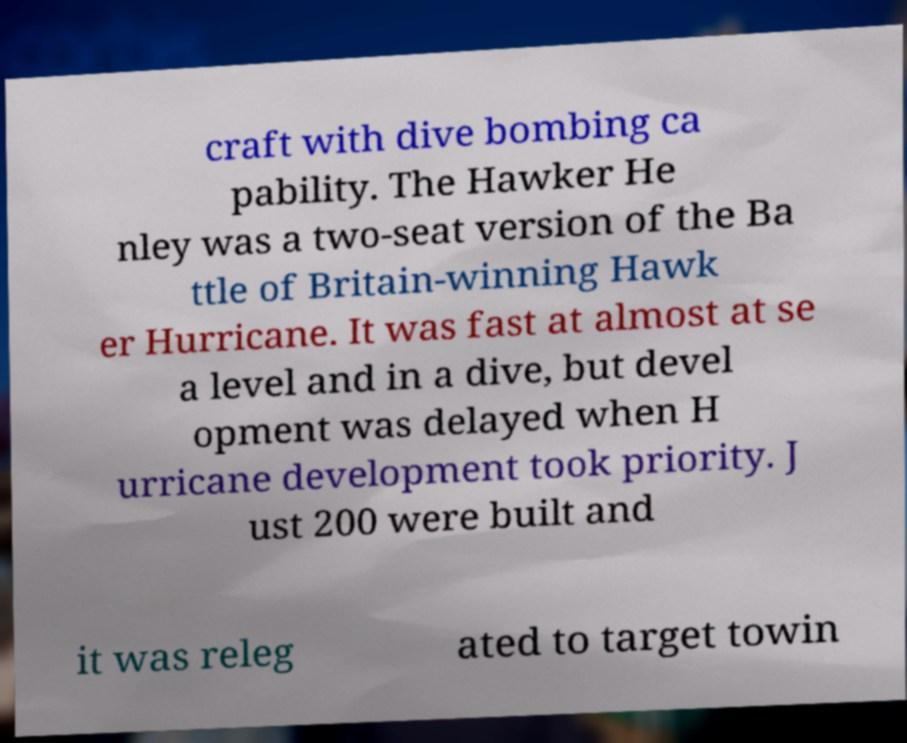Can you read and provide the text displayed in the image?This photo seems to have some interesting text. Can you extract and type it out for me? craft with dive bombing ca pability. The Hawker He nley was a two-seat version of the Ba ttle of Britain-winning Hawk er Hurricane. It was fast at almost at se a level and in a dive, but devel opment was delayed when H urricane development took priority. J ust 200 were built and it was releg ated to target towin 